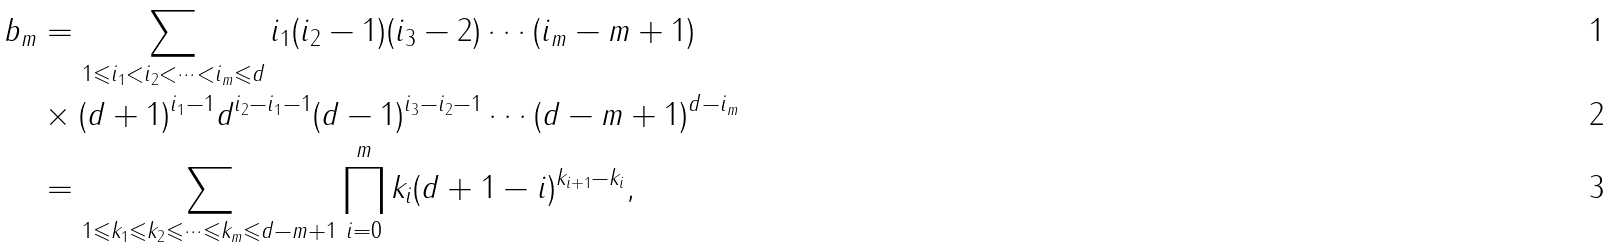Convert formula to latex. <formula><loc_0><loc_0><loc_500><loc_500>b _ { m } & = \sum _ { 1 \leqslant i _ { 1 } < i _ { 2 } < \cdots < i _ { m } \leqslant d } i _ { 1 } ( i _ { 2 } - 1 ) ( i _ { 3 } - 2 ) \cdots ( i _ { m } - m + 1 ) \\ & \times ( d + 1 ) ^ { i _ { 1 } - 1 } d ^ { i _ { 2 } - i _ { 1 } - 1 } ( d - 1 ) ^ { i _ { 3 } - i _ { 2 } - 1 } \cdots ( d - m + 1 ) ^ { d - i _ { m } } \\ & = \sum _ { 1 \leqslant k _ { 1 } \leqslant k _ { 2 } \leqslant \cdots \leqslant k _ { m } \leqslant d - m + 1 } \prod _ { i = 0 } ^ { m } k _ { i } ( d + 1 - i ) ^ { k _ { i + 1 } - k _ { i } } ,</formula> 